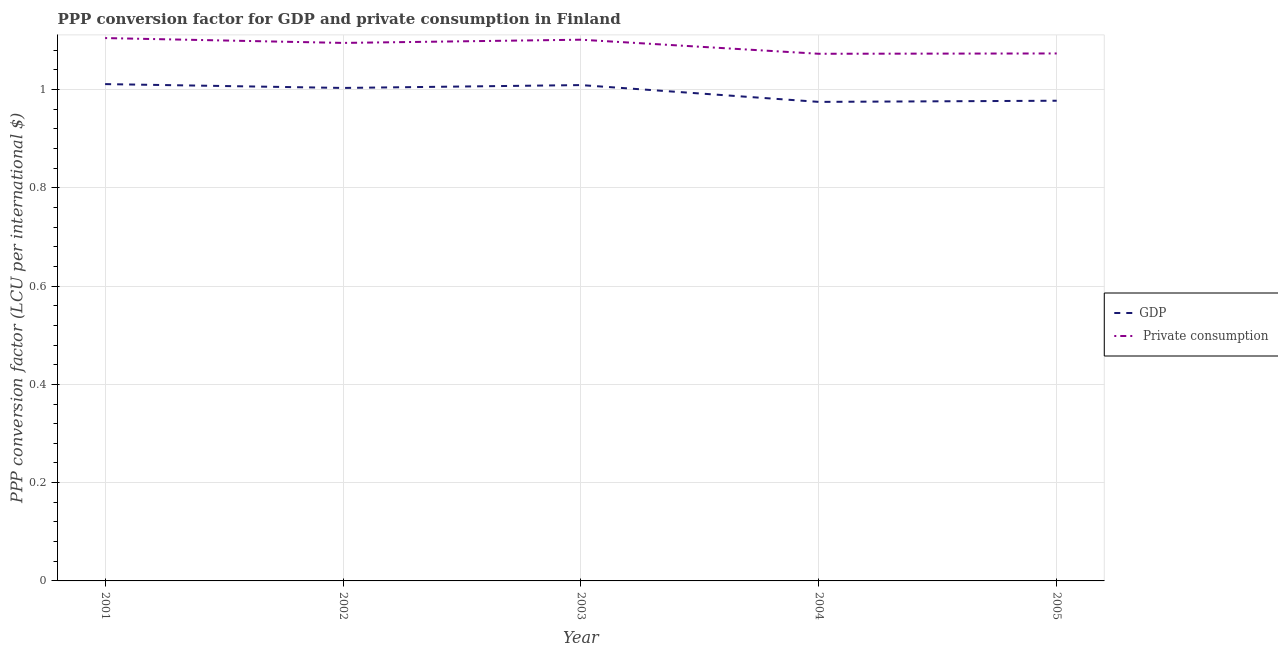How many different coloured lines are there?
Offer a terse response. 2. Does the line corresponding to ppp conversion factor for private consumption intersect with the line corresponding to ppp conversion factor for gdp?
Provide a short and direct response. No. Is the number of lines equal to the number of legend labels?
Keep it short and to the point. Yes. What is the ppp conversion factor for private consumption in 2005?
Provide a short and direct response. 1.07. Across all years, what is the maximum ppp conversion factor for private consumption?
Ensure brevity in your answer.  1.1. Across all years, what is the minimum ppp conversion factor for gdp?
Make the answer very short. 0.97. In which year was the ppp conversion factor for gdp minimum?
Offer a terse response. 2004. What is the total ppp conversion factor for private consumption in the graph?
Keep it short and to the point. 5.45. What is the difference between the ppp conversion factor for private consumption in 2001 and that in 2004?
Your answer should be very brief. 0.03. What is the difference between the ppp conversion factor for private consumption in 2002 and the ppp conversion factor for gdp in 2001?
Offer a very short reply. 0.08. What is the average ppp conversion factor for private consumption per year?
Your answer should be very brief. 1.09. In the year 2001, what is the difference between the ppp conversion factor for gdp and ppp conversion factor for private consumption?
Provide a short and direct response. -0.09. In how many years, is the ppp conversion factor for private consumption greater than 0.8400000000000001 LCU?
Make the answer very short. 5. What is the ratio of the ppp conversion factor for gdp in 2004 to that in 2005?
Offer a terse response. 1. Is the ppp conversion factor for gdp in 2004 less than that in 2005?
Make the answer very short. Yes. What is the difference between the highest and the second highest ppp conversion factor for gdp?
Provide a short and direct response. 0. What is the difference between the highest and the lowest ppp conversion factor for gdp?
Offer a very short reply. 0.04. In how many years, is the ppp conversion factor for private consumption greater than the average ppp conversion factor for private consumption taken over all years?
Provide a succinct answer. 3. How many lines are there?
Keep it short and to the point. 2. How many years are there in the graph?
Provide a short and direct response. 5. What is the difference between two consecutive major ticks on the Y-axis?
Offer a very short reply. 0.2. Does the graph contain any zero values?
Your answer should be very brief. No. What is the title of the graph?
Give a very brief answer. PPP conversion factor for GDP and private consumption in Finland. What is the label or title of the Y-axis?
Ensure brevity in your answer.  PPP conversion factor (LCU per international $). What is the PPP conversion factor (LCU per international $) of GDP in 2001?
Offer a very short reply. 1.01. What is the PPP conversion factor (LCU per international $) of  Private consumption in 2001?
Provide a short and direct response. 1.1. What is the PPP conversion factor (LCU per international $) in GDP in 2002?
Ensure brevity in your answer.  1. What is the PPP conversion factor (LCU per international $) in  Private consumption in 2002?
Your answer should be very brief. 1.09. What is the PPP conversion factor (LCU per international $) of GDP in 2003?
Your response must be concise. 1.01. What is the PPP conversion factor (LCU per international $) in  Private consumption in 2003?
Your answer should be compact. 1.1. What is the PPP conversion factor (LCU per international $) of GDP in 2004?
Your answer should be very brief. 0.97. What is the PPP conversion factor (LCU per international $) of  Private consumption in 2004?
Offer a very short reply. 1.07. What is the PPP conversion factor (LCU per international $) of GDP in 2005?
Your response must be concise. 0.98. What is the PPP conversion factor (LCU per international $) in  Private consumption in 2005?
Provide a short and direct response. 1.07. Across all years, what is the maximum PPP conversion factor (LCU per international $) of GDP?
Your answer should be compact. 1.01. Across all years, what is the maximum PPP conversion factor (LCU per international $) of  Private consumption?
Offer a very short reply. 1.1. Across all years, what is the minimum PPP conversion factor (LCU per international $) of GDP?
Give a very brief answer. 0.97. Across all years, what is the minimum PPP conversion factor (LCU per international $) in  Private consumption?
Give a very brief answer. 1.07. What is the total PPP conversion factor (LCU per international $) in GDP in the graph?
Your response must be concise. 4.98. What is the total PPP conversion factor (LCU per international $) in  Private consumption in the graph?
Provide a short and direct response. 5.45. What is the difference between the PPP conversion factor (LCU per international $) of GDP in 2001 and that in 2002?
Make the answer very short. 0.01. What is the difference between the PPP conversion factor (LCU per international $) of  Private consumption in 2001 and that in 2002?
Ensure brevity in your answer.  0.01. What is the difference between the PPP conversion factor (LCU per international $) in GDP in 2001 and that in 2003?
Make the answer very short. 0. What is the difference between the PPP conversion factor (LCU per international $) of  Private consumption in 2001 and that in 2003?
Keep it short and to the point. 0. What is the difference between the PPP conversion factor (LCU per international $) of GDP in 2001 and that in 2004?
Give a very brief answer. 0.04. What is the difference between the PPP conversion factor (LCU per international $) of  Private consumption in 2001 and that in 2004?
Your response must be concise. 0.03. What is the difference between the PPP conversion factor (LCU per international $) of GDP in 2001 and that in 2005?
Provide a succinct answer. 0.03. What is the difference between the PPP conversion factor (LCU per international $) in  Private consumption in 2001 and that in 2005?
Your answer should be very brief. 0.03. What is the difference between the PPP conversion factor (LCU per international $) of GDP in 2002 and that in 2003?
Give a very brief answer. -0.01. What is the difference between the PPP conversion factor (LCU per international $) in  Private consumption in 2002 and that in 2003?
Ensure brevity in your answer.  -0.01. What is the difference between the PPP conversion factor (LCU per international $) of GDP in 2002 and that in 2004?
Your response must be concise. 0.03. What is the difference between the PPP conversion factor (LCU per international $) of  Private consumption in 2002 and that in 2004?
Offer a very short reply. 0.02. What is the difference between the PPP conversion factor (LCU per international $) in GDP in 2002 and that in 2005?
Your answer should be compact. 0.03. What is the difference between the PPP conversion factor (LCU per international $) in  Private consumption in 2002 and that in 2005?
Provide a short and direct response. 0.02. What is the difference between the PPP conversion factor (LCU per international $) in GDP in 2003 and that in 2004?
Your answer should be very brief. 0.03. What is the difference between the PPP conversion factor (LCU per international $) in  Private consumption in 2003 and that in 2004?
Your response must be concise. 0.03. What is the difference between the PPP conversion factor (LCU per international $) of GDP in 2003 and that in 2005?
Keep it short and to the point. 0.03. What is the difference between the PPP conversion factor (LCU per international $) of  Private consumption in 2003 and that in 2005?
Keep it short and to the point. 0.03. What is the difference between the PPP conversion factor (LCU per international $) of GDP in 2004 and that in 2005?
Offer a terse response. -0. What is the difference between the PPP conversion factor (LCU per international $) of  Private consumption in 2004 and that in 2005?
Give a very brief answer. -0. What is the difference between the PPP conversion factor (LCU per international $) of GDP in 2001 and the PPP conversion factor (LCU per international $) of  Private consumption in 2002?
Provide a succinct answer. -0.08. What is the difference between the PPP conversion factor (LCU per international $) in GDP in 2001 and the PPP conversion factor (LCU per international $) in  Private consumption in 2003?
Your response must be concise. -0.09. What is the difference between the PPP conversion factor (LCU per international $) of GDP in 2001 and the PPP conversion factor (LCU per international $) of  Private consumption in 2004?
Ensure brevity in your answer.  -0.06. What is the difference between the PPP conversion factor (LCU per international $) of GDP in 2001 and the PPP conversion factor (LCU per international $) of  Private consumption in 2005?
Keep it short and to the point. -0.06. What is the difference between the PPP conversion factor (LCU per international $) of GDP in 2002 and the PPP conversion factor (LCU per international $) of  Private consumption in 2003?
Give a very brief answer. -0.1. What is the difference between the PPP conversion factor (LCU per international $) of GDP in 2002 and the PPP conversion factor (LCU per international $) of  Private consumption in 2004?
Offer a terse response. -0.07. What is the difference between the PPP conversion factor (LCU per international $) in GDP in 2002 and the PPP conversion factor (LCU per international $) in  Private consumption in 2005?
Ensure brevity in your answer.  -0.07. What is the difference between the PPP conversion factor (LCU per international $) in GDP in 2003 and the PPP conversion factor (LCU per international $) in  Private consumption in 2004?
Provide a succinct answer. -0.06. What is the difference between the PPP conversion factor (LCU per international $) in GDP in 2003 and the PPP conversion factor (LCU per international $) in  Private consumption in 2005?
Ensure brevity in your answer.  -0.06. What is the difference between the PPP conversion factor (LCU per international $) of GDP in 2004 and the PPP conversion factor (LCU per international $) of  Private consumption in 2005?
Offer a terse response. -0.1. What is the average PPP conversion factor (LCU per international $) in  Private consumption per year?
Keep it short and to the point. 1.09. In the year 2001, what is the difference between the PPP conversion factor (LCU per international $) in GDP and PPP conversion factor (LCU per international $) in  Private consumption?
Provide a succinct answer. -0.09. In the year 2002, what is the difference between the PPP conversion factor (LCU per international $) of GDP and PPP conversion factor (LCU per international $) of  Private consumption?
Keep it short and to the point. -0.09. In the year 2003, what is the difference between the PPP conversion factor (LCU per international $) in GDP and PPP conversion factor (LCU per international $) in  Private consumption?
Offer a terse response. -0.09. In the year 2004, what is the difference between the PPP conversion factor (LCU per international $) in GDP and PPP conversion factor (LCU per international $) in  Private consumption?
Make the answer very short. -0.1. In the year 2005, what is the difference between the PPP conversion factor (LCU per international $) in GDP and PPP conversion factor (LCU per international $) in  Private consumption?
Offer a terse response. -0.1. What is the ratio of the PPP conversion factor (LCU per international $) of GDP in 2001 to that in 2002?
Your answer should be compact. 1.01. What is the ratio of the PPP conversion factor (LCU per international $) in GDP in 2001 to that in 2003?
Your response must be concise. 1. What is the ratio of the PPP conversion factor (LCU per international $) of GDP in 2001 to that in 2004?
Provide a succinct answer. 1.04. What is the ratio of the PPP conversion factor (LCU per international $) in  Private consumption in 2001 to that in 2004?
Your response must be concise. 1.03. What is the ratio of the PPP conversion factor (LCU per international $) of GDP in 2001 to that in 2005?
Provide a succinct answer. 1.03. What is the ratio of the PPP conversion factor (LCU per international $) of  Private consumption in 2001 to that in 2005?
Offer a terse response. 1.03. What is the ratio of the PPP conversion factor (LCU per international $) in  Private consumption in 2002 to that in 2003?
Your response must be concise. 0.99. What is the ratio of the PPP conversion factor (LCU per international $) in GDP in 2002 to that in 2004?
Offer a very short reply. 1.03. What is the ratio of the PPP conversion factor (LCU per international $) of  Private consumption in 2002 to that in 2004?
Your response must be concise. 1.02. What is the ratio of the PPP conversion factor (LCU per international $) of GDP in 2002 to that in 2005?
Your answer should be very brief. 1.03. What is the ratio of the PPP conversion factor (LCU per international $) of GDP in 2003 to that in 2004?
Offer a very short reply. 1.04. What is the ratio of the PPP conversion factor (LCU per international $) in  Private consumption in 2003 to that in 2004?
Your response must be concise. 1.03. What is the ratio of the PPP conversion factor (LCU per international $) of GDP in 2003 to that in 2005?
Provide a short and direct response. 1.03. What is the ratio of the PPP conversion factor (LCU per international $) in  Private consumption in 2003 to that in 2005?
Your answer should be compact. 1.03. What is the ratio of the PPP conversion factor (LCU per international $) of  Private consumption in 2004 to that in 2005?
Provide a short and direct response. 1. What is the difference between the highest and the second highest PPP conversion factor (LCU per international $) of GDP?
Give a very brief answer. 0. What is the difference between the highest and the second highest PPP conversion factor (LCU per international $) of  Private consumption?
Offer a terse response. 0. What is the difference between the highest and the lowest PPP conversion factor (LCU per international $) in GDP?
Offer a terse response. 0.04. What is the difference between the highest and the lowest PPP conversion factor (LCU per international $) in  Private consumption?
Keep it short and to the point. 0.03. 